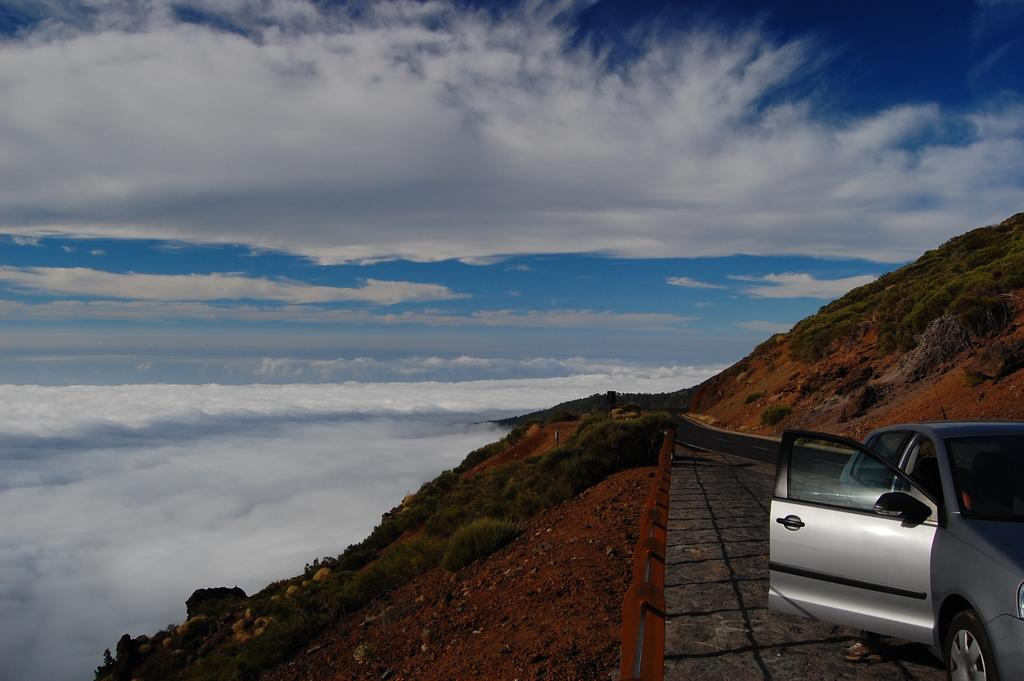What is the main subject of the image? There is a vehicle in the image. What can be seen in the background of the image? There are trees in the background of the image. What is the color of the trees in the image? The trees are green. What is visible above the trees in the image? The sky is visible in the image. What are the colors of the sky in the image? The sky is blue and white in color. What type of doctor can be seen holding an umbrella in the image? There is no doctor or umbrella present in the image. What type of calculations can be performed using the calculator in the image? There is no calculator present in the image. 